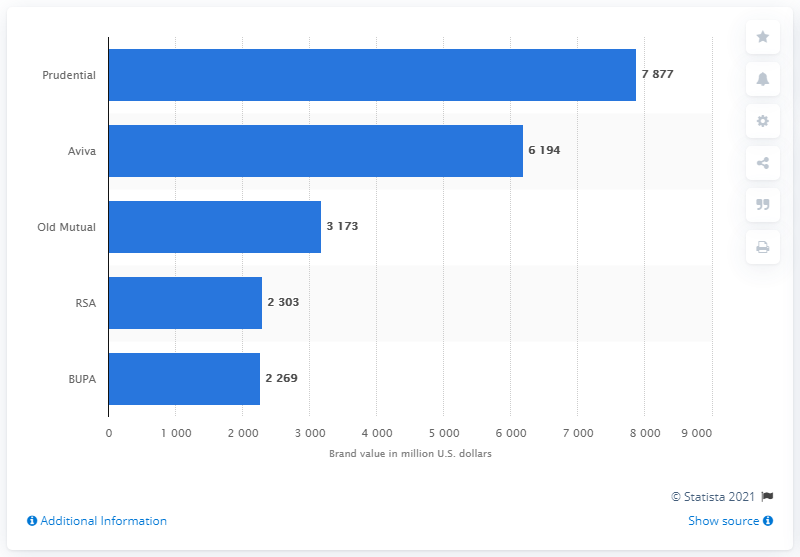What was Prudential's brand value in US dollars? Based on the bar graph provided in the image, Prudential's brand value is approximately $7.877 billion USD. This figure is the highest among the compared insurance brands, indicating Prudential's strong market presence and brand valuation. 